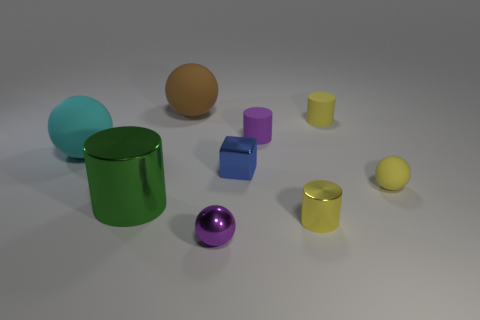What color is the other metal object that is the same shape as the big metal object?
Your answer should be compact. Yellow. Is there a sphere that has the same color as the small metal cylinder?
Your answer should be compact. Yes. Do the cyan object and the yellow cylinder that is in front of the cyan rubber sphere have the same material?
Your answer should be very brief. No. There is a tiny sphere behind the small metal ball; is there a sphere that is in front of it?
Your answer should be very brief. Yes. What color is the tiny metallic thing that is in front of the small blue block and on the left side of the small purple rubber cylinder?
Your answer should be compact. Purple. What size is the purple metallic sphere?
Keep it short and to the point. Small. What number of yellow metal cylinders are the same size as the green thing?
Offer a terse response. 0. Are the sphere behind the large cyan matte object and the purple thing that is in front of the small yellow sphere made of the same material?
Provide a short and direct response. No. What material is the blue cube that is to the right of the rubber thing that is on the left side of the green metallic object?
Provide a short and direct response. Metal. What is the big thing in front of the tiny yellow ball made of?
Provide a short and direct response. Metal. 